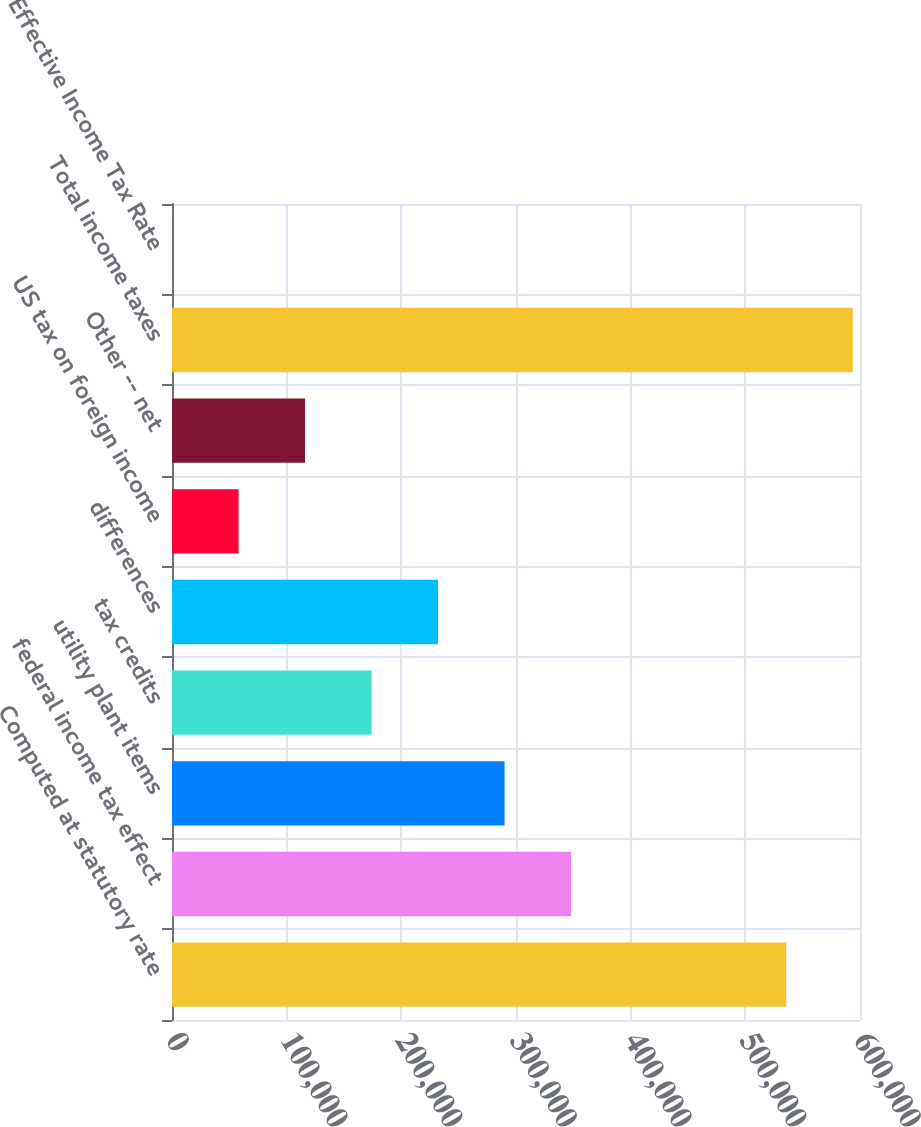Convert chart to OTSL. <chart><loc_0><loc_0><loc_500><loc_500><bar_chart><fcel>Computed at statutory rate<fcel>federal income tax effect<fcel>utility plant items<fcel>tax credits<fcel>differences<fcel>US tax on foreign income<fcel>Other -- net<fcel>Total income taxes<fcel>Effective Income Tax Rate<nl><fcel>535663<fcel>348015<fcel>290018<fcel>174026<fcel>232022<fcel>58034<fcel>116030<fcel>593659<fcel>37.9<nl></chart> 